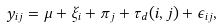<formula> <loc_0><loc_0><loc_500><loc_500>y _ { i j } = \mu + \xi _ { i } + \pi _ { j } + \tau _ { d } ( i , j ) + \epsilon _ { i j } ,</formula> 